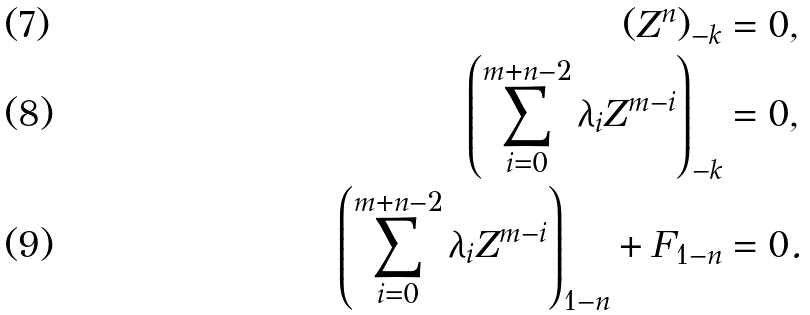Convert formula to latex. <formula><loc_0><loc_0><loc_500><loc_500>( Z ^ { n } ) _ { - k } & = 0 , & & \\ \left ( \sum _ { i = 0 } ^ { m + n - 2 } \lambda _ { i } Z ^ { m - i } \right ) _ { - k } & = 0 , & & \\ \left ( \sum _ { i = 0 } ^ { m + n - 2 } \lambda _ { i } Z ^ { m - i } \right ) _ { 1 - n } + F _ { 1 - n } & = 0 .</formula> 